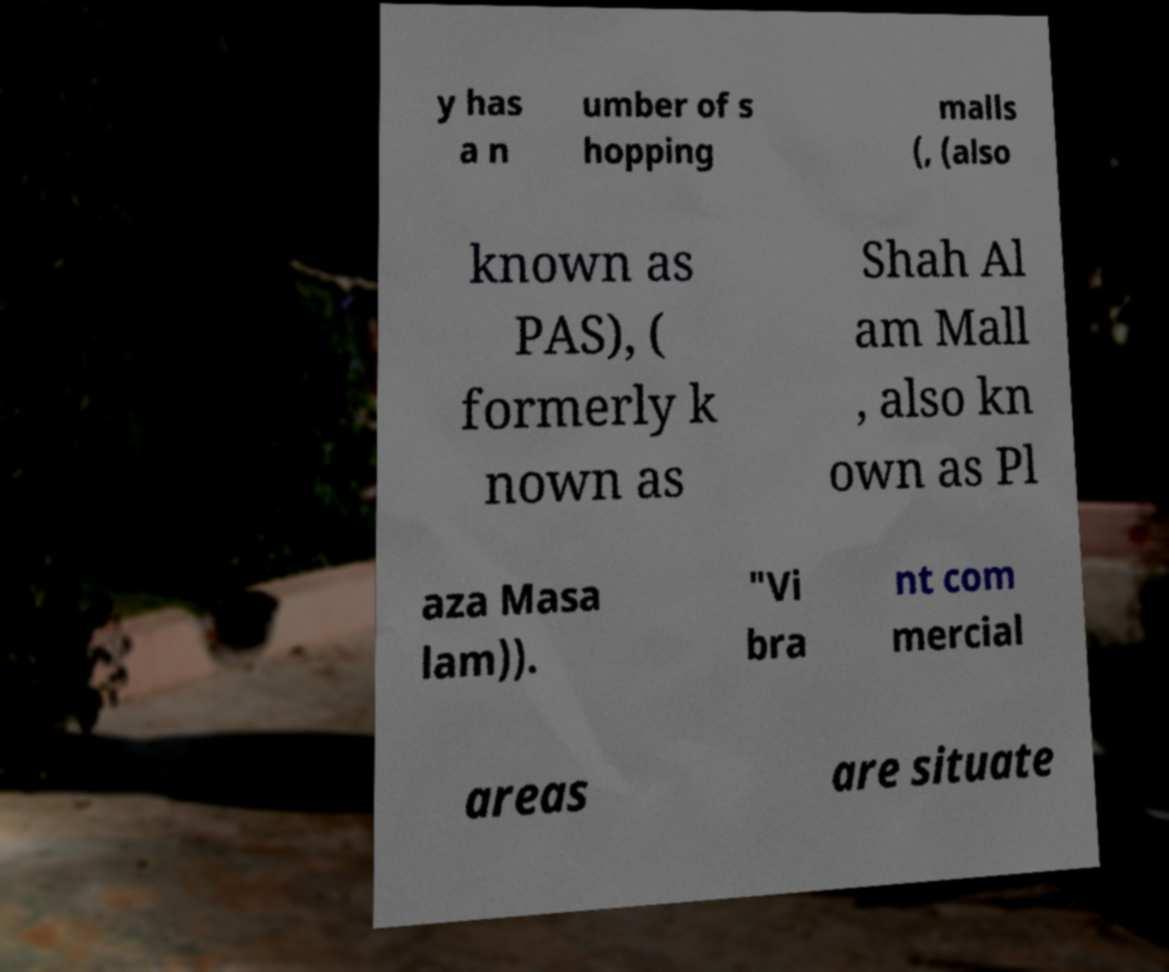For documentation purposes, I need the text within this image transcribed. Could you provide that? y has a n umber of s hopping malls (, (also known as PAS), ( formerly k nown as Shah Al am Mall , also kn own as Pl aza Masa lam)). "Vi bra nt com mercial areas are situate 